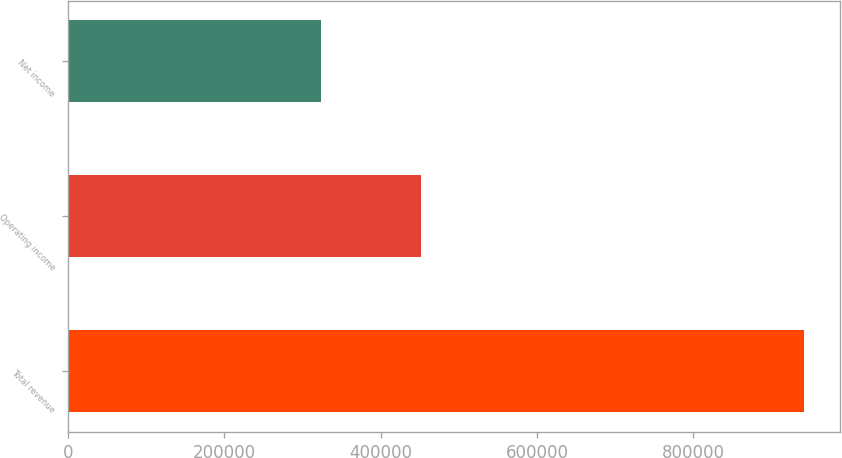<chart> <loc_0><loc_0><loc_500><loc_500><bar_chart><fcel>Total revenue<fcel>Operating income<fcel>Net income<nl><fcel>941442<fcel>451853<fcel>323409<nl></chart> 